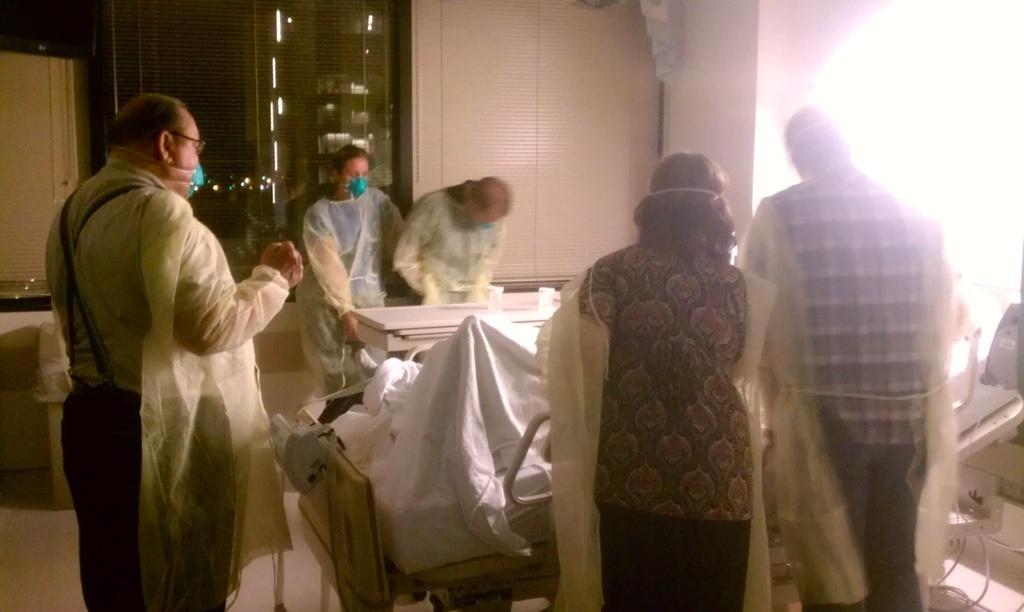How would you summarize this image in a sentence or two? in this image it might be operation theater, there are few people visible and they are wearing mask, in the middle there is a table, on which there are two glasses kept on it, in front of table there is a bed,on which there might be a person laying on bed, covering with bed sheet, on the right side there is a light focus, wires, at the top there is the wall, window. 